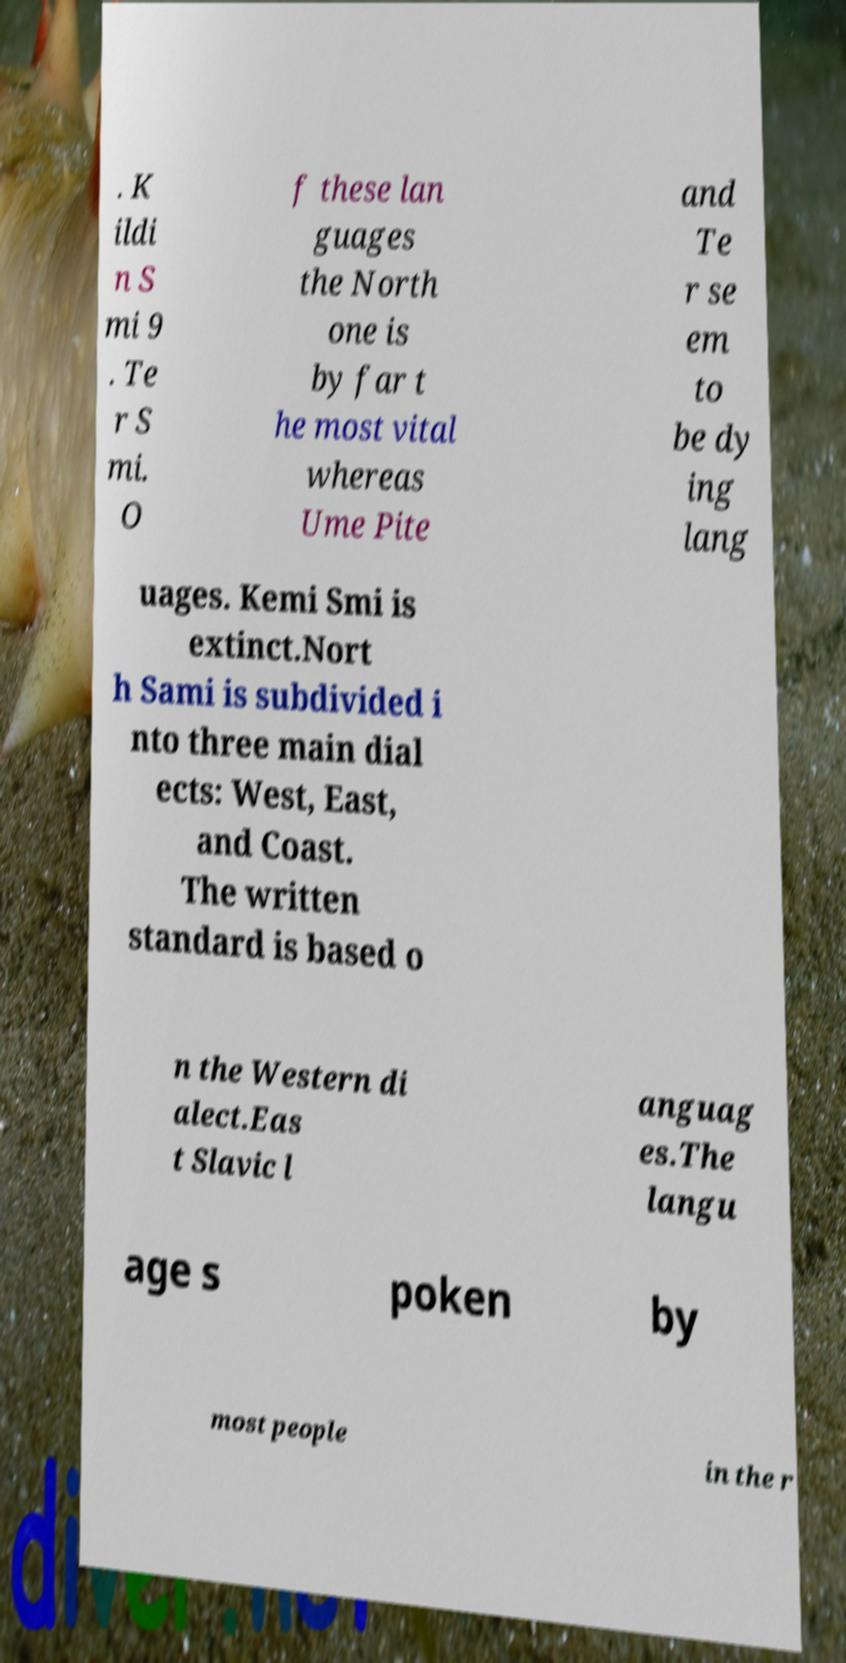Can you accurately transcribe the text from the provided image for me? . K ildi n S mi 9 . Te r S mi. O f these lan guages the North one is by far t he most vital whereas Ume Pite and Te r se em to be dy ing lang uages. Kemi Smi is extinct.Nort h Sami is subdivided i nto three main dial ects: West, East, and Coast. The written standard is based o n the Western di alect.Eas t Slavic l anguag es.The langu age s poken by most people in the r 